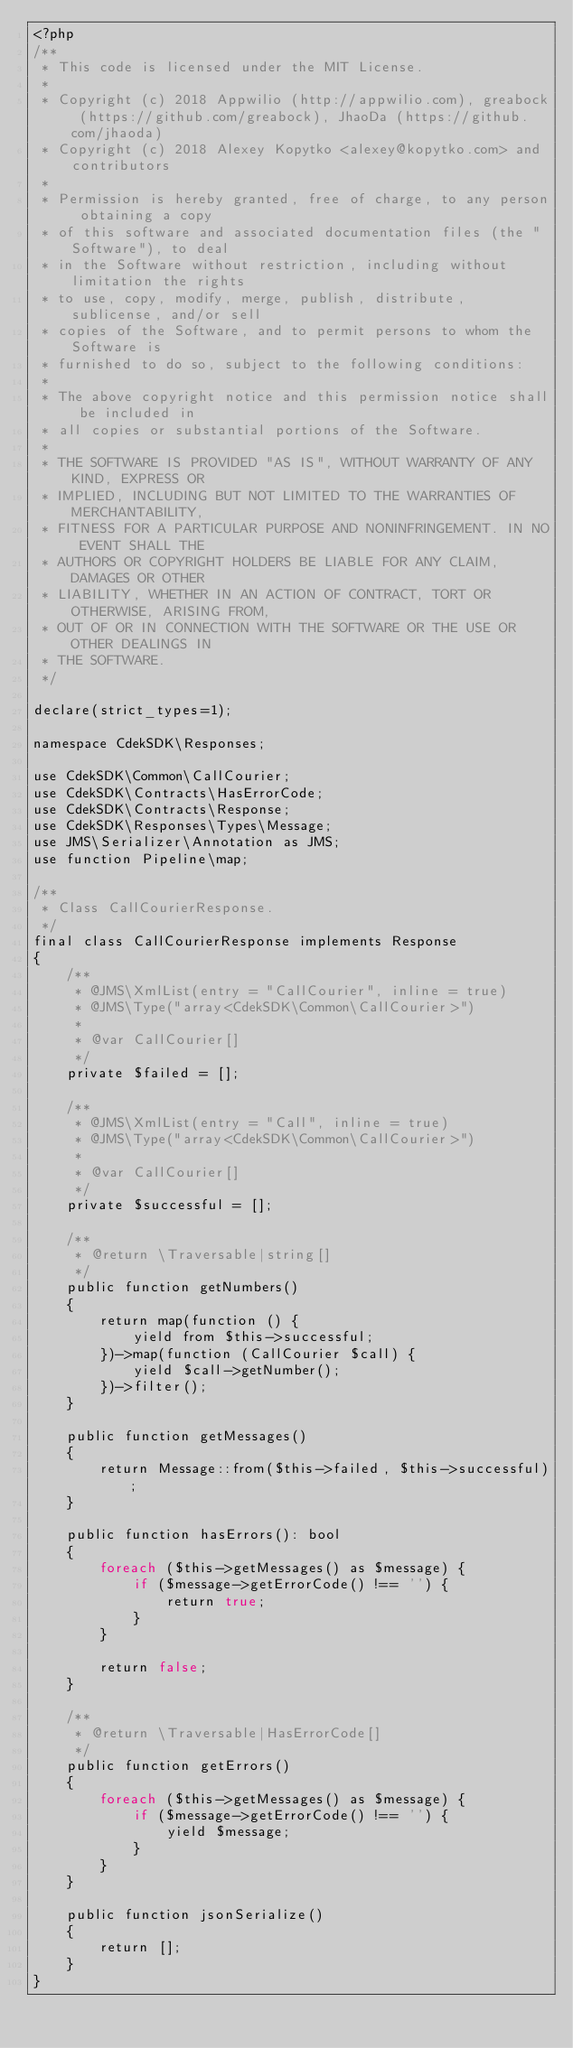Convert code to text. <code><loc_0><loc_0><loc_500><loc_500><_PHP_><?php
/**
 * This code is licensed under the MIT License.
 *
 * Copyright (c) 2018 Appwilio (http://appwilio.com), greabock (https://github.com/greabock), JhaoDa (https://github.com/jhaoda)
 * Copyright (c) 2018 Alexey Kopytko <alexey@kopytko.com> and contributors
 *
 * Permission is hereby granted, free of charge, to any person obtaining a copy
 * of this software and associated documentation files (the "Software"), to deal
 * in the Software without restriction, including without limitation the rights
 * to use, copy, modify, merge, publish, distribute, sublicense, and/or sell
 * copies of the Software, and to permit persons to whom the Software is
 * furnished to do so, subject to the following conditions:
 *
 * The above copyright notice and this permission notice shall be included in
 * all copies or substantial portions of the Software.
 *
 * THE SOFTWARE IS PROVIDED "AS IS", WITHOUT WARRANTY OF ANY KIND, EXPRESS OR
 * IMPLIED, INCLUDING BUT NOT LIMITED TO THE WARRANTIES OF MERCHANTABILITY,
 * FITNESS FOR A PARTICULAR PURPOSE AND NONINFRINGEMENT. IN NO EVENT SHALL THE
 * AUTHORS OR COPYRIGHT HOLDERS BE LIABLE FOR ANY CLAIM, DAMAGES OR OTHER
 * LIABILITY, WHETHER IN AN ACTION OF CONTRACT, TORT OR OTHERWISE, ARISING FROM,
 * OUT OF OR IN CONNECTION WITH THE SOFTWARE OR THE USE OR OTHER DEALINGS IN
 * THE SOFTWARE.
 */

declare(strict_types=1);

namespace CdekSDK\Responses;

use CdekSDK\Common\CallCourier;
use CdekSDK\Contracts\HasErrorCode;
use CdekSDK\Contracts\Response;
use CdekSDK\Responses\Types\Message;
use JMS\Serializer\Annotation as JMS;
use function Pipeline\map;

/**
 * Class CallCourierResponse.
 */
final class CallCourierResponse implements Response
{
    /**
     * @JMS\XmlList(entry = "CallCourier", inline = true)
     * @JMS\Type("array<CdekSDK\Common\CallCourier>")
     *
     * @var CallCourier[]
     */
    private $failed = [];

    /**
     * @JMS\XmlList(entry = "Call", inline = true)
     * @JMS\Type("array<CdekSDK\Common\CallCourier>")
     *
     * @var CallCourier[]
     */
    private $successful = [];

    /**
     * @return \Traversable|string[]
     */
    public function getNumbers()
    {
        return map(function () {
            yield from $this->successful;
        })->map(function (CallCourier $call) {
            yield $call->getNumber();
        })->filter();
    }

    public function getMessages()
    {
        return Message::from($this->failed, $this->successful);
    }

    public function hasErrors(): bool
    {
        foreach ($this->getMessages() as $message) {
            if ($message->getErrorCode() !== '') {
                return true;
            }
        }

        return false;
    }

    /**
     * @return \Traversable|HasErrorCode[]
     */
    public function getErrors()
    {
        foreach ($this->getMessages() as $message) {
            if ($message->getErrorCode() !== '') {
                yield $message;
            }
        }
    }

    public function jsonSerialize()
    {
        return [];
    }
}
</code> 